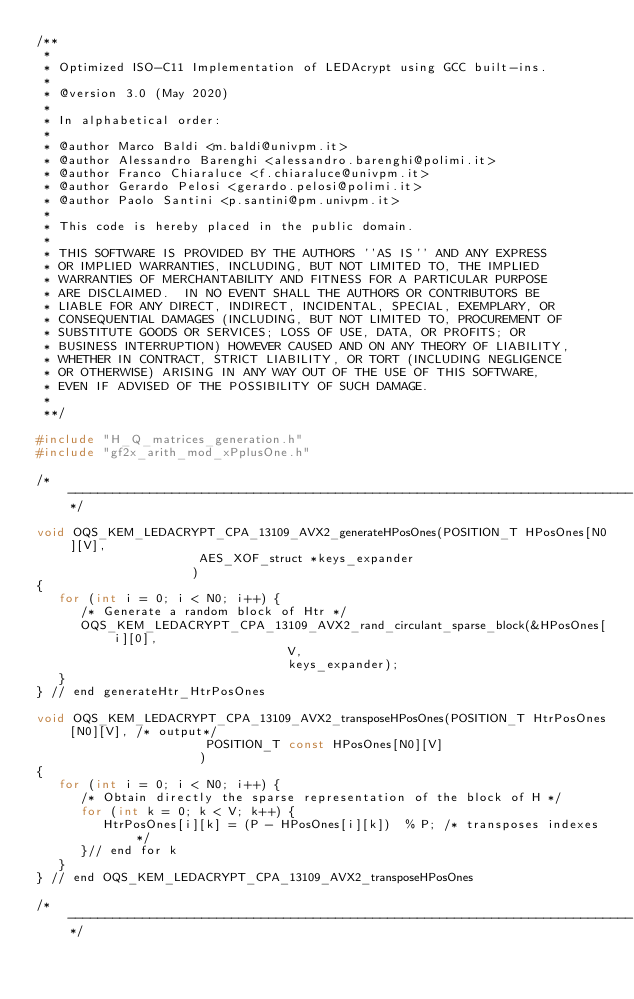Convert code to text. <code><loc_0><loc_0><loc_500><loc_500><_C_>/**
 *
 * Optimized ISO-C11 Implementation of LEDAcrypt using GCC built-ins.
 *
 * @version 3.0 (May 2020)
 *
 * In alphabetical order:
 *
 * @author Marco Baldi <m.baldi@univpm.it>
 * @author Alessandro Barenghi <alessandro.barenghi@polimi.it>
 * @author Franco Chiaraluce <f.chiaraluce@univpm.it>
 * @author Gerardo Pelosi <gerardo.pelosi@polimi.it>
 * @author Paolo Santini <p.santini@pm.univpm.it>
 *
 * This code is hereby placed in the public domain.
 *
 * THIS SOFTWARE IS PROVIDED BY THE AUTHORS ''AS IS'' AND ANY EXPRESS
 * OR IMPLIED WARRANTIES, INCLUDING, BUT NOT LIMITED TO, THE IMPLIED
 * WARRANTIES OF MERCHANTABILITY AND FITNESS FOR A PARTICULAR PURPOSE
 * ARE DISCLAIMED.  IN NO EVENT SHALL THE AUTHORS OR CONTRIBUTORS BE
 * LIABLE FOR ANY DIRECT, INDIRECT, INCIDENTAL, SPECIAL, EXEMPLARY, OR
 * CONSEQUENTIAL DAMAGES (INCLUDING, BUT NOT LIMITED TO, PROCUREMENT OF
 * SUBSTITUTE GOODS OR SERVICES; LOSS OF USE, DATA, OR PROFITS; OR
 * BUSINESS INTERRUPTION) HOWEVER CAUSED AND ON ANY THEORY OF LIABILITY,
 * WHETHER IN CONTRACT, STRICT LIABILITY, OR TORT (INCLUDING NEGLIGENCE
 * OR OTHERWISE) ARISING IN ANY WAY OUT OF THE USE OF THIS SOFTWARE,
 * EVEN IF ADVISED OF THE POSSIBILITY OF SUCH DAMAGE.
 *
 **/

#include "H_Q_matrices_generation.h"
#include "gf2x_arith_mod_xPplusOne.h"

/*----------------------------------------------------------------------------*/

void OQS_KEM_LEDACRYPT_CPA_13109_AVX2_generateHPosOnes(POSITION_T HPosOnes[N0][V],
                      AES_XOF_struct *keys_expander
                     )
{
   for (int i = 0; i < N0; i++) {
      /* Generate a random block of Htr */
      OQS_KEM_LEDACRYPT_CPA_13109_AVX2_rand_circulant_sparse_block(&HPosOnes[i][0],
                                  V,
                                  keys_expander);
   }
} // end generateHtr_HtrPosOnes

void OQS_KEM_LEDACRYPT_CPA_13109_AVX2_transposeHPosOnes(POSITION_T HtrPosOnes[N0][V], /* output*/
                       POSITION_T const HPosOnes[N0][V]
                      )
{
   for (int i = 0; i < N0; i++) {
      /* Obtain directly the sparse representation of the block of H */
      for (int k = 0; k < V; k++) {
         HtrPosOnes[i][k] = (P - HPosOnes[i][k])  % P; /* transposes indexes */
      }// end for k
   }
} // end OQS_KEM_LEDACRYPT_CPA_13109_AVX2_transposeHPosOnes

/*----------------------------------------------------------------------------*/
</code> 